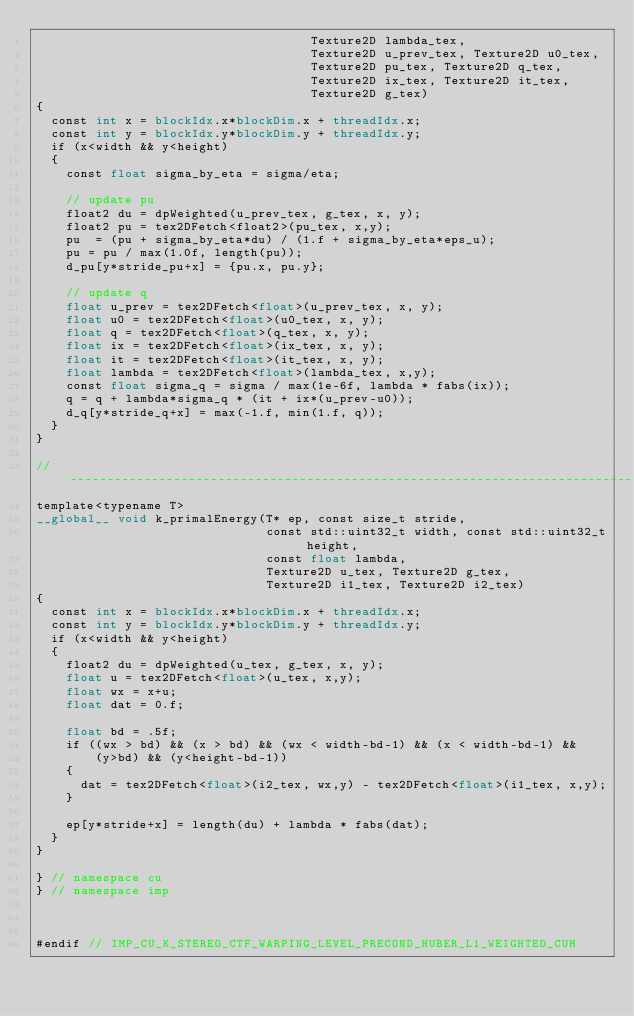Convert code to text. <code><loc_0><loc_0><loc_500><loc_500><_Cuda_>                                     Texture2D lambda_tex,
                                     Texture2D u_prev_tex, Texture2D u0_tex,
                                     Texture2D pu_tex, Texture2D q_tex,
                                     Texture2D ix_tex, Texture2D it_tex,
                                     Texture2D g_tex)
{
  const int x = blockIdx.x*blockDim.x + threadIdx.x;
  const int y = blockIdx.y*blockDim.y + threadIdx.y;
  if (x<width && y<height)
  {
    const float sigma_by_eta = sigma/eta;

    // update pu
    float2 du = dpWeighted(u_prev_tex, g_tex, x, y);
    float2 pu = tex2DFetch<float2>(pu_tex, x,y);
    pu  = (pu + sigma_by_eta*du) / (1.f + sigma_by_eta*eps_u);
    pu = pu / max(1.0f, length(pu));
    d_pu[y*stride_pu+x] = {pu.x, pu.y};

    // update q
    float u_prev = tex2DFetch<float>(u_prev_tex, x, y);
    float u0 = tex2DFetch<float>(u0_tex, x, y);
    float q = tex2DFetch<float>(q_tex, x, y);
    float ix = tex2DFetch<float>(ix_tex, x, y);
    float it = tex2DFetch<float>(it_tex, x, y);
    float lambda = tex2DFetch<float>(lambda_tex, x,y);
    const float sigma_q = sigma / max(1e-6f, lambda * fabs(ix));
    q = q + lambda*sigma_q * (it + ix*(u_prev-u0));
    d_q[y*stride_q+x] = max(-1.f, min(1.f, q));
  }
}

//-----------------------------------------------------------------------------
template<typename T>
__global__ void k_primalEnergy(T* ep, const size_t stride,
                               const std::uint32_t width, const std::uint32_t height,
                               const float lambda,
                               Texture2D u_tex, Texture2D g_tex,
                               Texture2D i1_tex, Texture2D i2_tex)
{
  const int x = blockIdx.x*blockDim.x + threadIdx.x;
  const int y = blockIdx.y*blockDim.y + threadIdx.y;
  if (x<width && y<height)
  {
    float2 du = dpWeighted(u_tex, g_tex, x, y);
    float u = tex2DFetch<float>(u_tex, x,y);
    float wx = x+u;
    float dat = 0.f;

    float bd = .5f;
    if ((wx > bd) && (x > bd) && (wx < width-bd-1) && (x < width-bd-1) &&
        (y>bd) && (y<height-bd-1))
    {
      dat = tex2DFetch<float>(i2_tex, wx,y) - tex2DFetch<float>(i1_tex, x,y);
    }

    ep[y*stride+x] = length(du) + lambda * fabs(dat);
  }
}

} // namespace cu
} // namespace imp



#endif // IMP_CU_K_STEREO_CTF_WARPING_LEVEL_PRECOND_HUBER_L1_WEIGHTED_CUH

</code> 